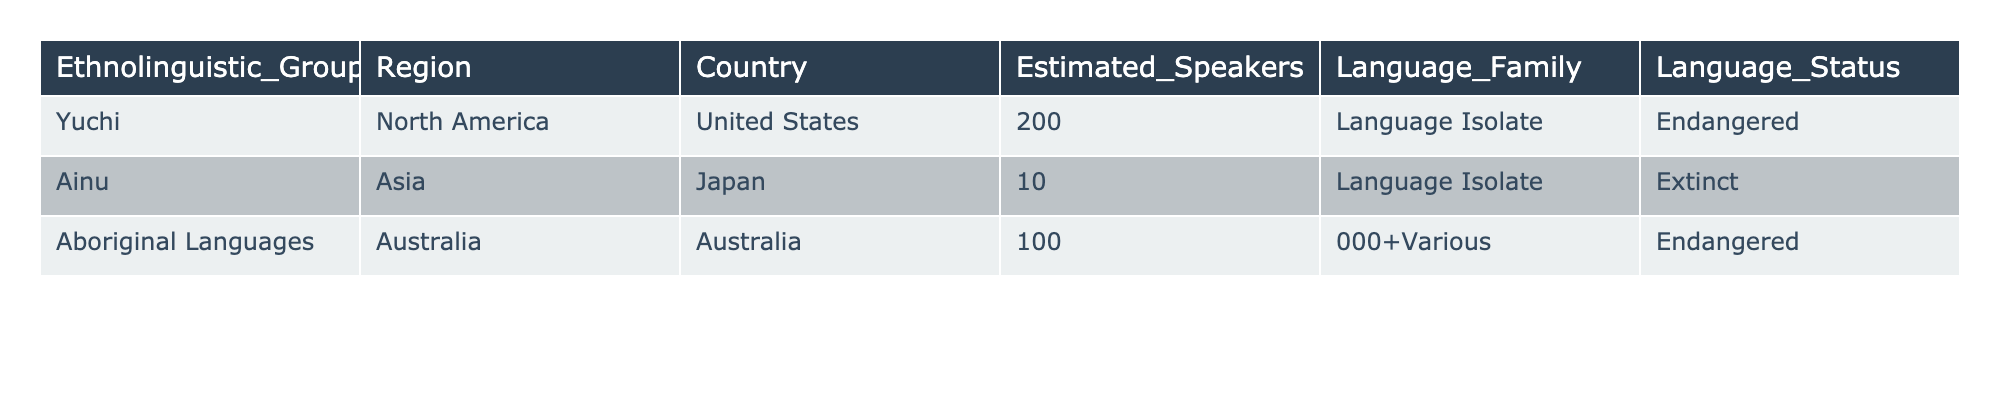What is the estimated number of speakers for the Yuchi language? The table specifies that the estimated number of speakers for the Yuchi language is 200.
Answer: 200 Which language family do the Aboriginal Languages belong to? The table shows that Aboriginal Languages belong to various language families, but it does not specify a single language family.
Answer: Various Is the Ainu language considered endangered? The table states that Ainu is marked as extinct, which means it is no longer spoken or is not in use.
Answer: No How many languages listed in the table are considered endangered? The Yuchi and Aboriginal Languages are marked as endangered, making it a total of 2 languages.
Answer: 2 Which region has the highest number of estimated speakers among the listed languages? The Aboriginal Languages have the highest estimated speakers listed as 100,000+, far exceeding the other languages.
Answer: Australia Is there a language in the table that is classified as a language isolate? Both Yuchi and Ainu are classified as language isolates in the table.
Answer: Yes If combined, how many estimated speakers are there for both endangered languages listed (Yuchi and Aboriginal Languages)? Yuchi has 200 speakers, and while the Aboriginal Languages have 100,000+, adding them together yields 100,200.
Answer: 100,200 What can be inferred about the status of the languages based on the table? The table indicates that one language is extinct, two are endangered, illustrating a concerning trend for these indigenous languages.
Answer: Decline in language status What is the total number of estimated speakers for all the languages reported in the table? Adding the speakers: 200 (Yuchi) + 10 (Ainu, which is extinct and effectively has no speakers) + 100,000+ (Aboriginal Languages) gives us around 100,200+.
Answer: 100,200+ How many countries in the table have indigenous languages that fall under the category of endangered? Two languages are classified as endangered and both are located in one country each: the United States for Yuchi and Australia for Aboriginal Languages.
Answer: 2 